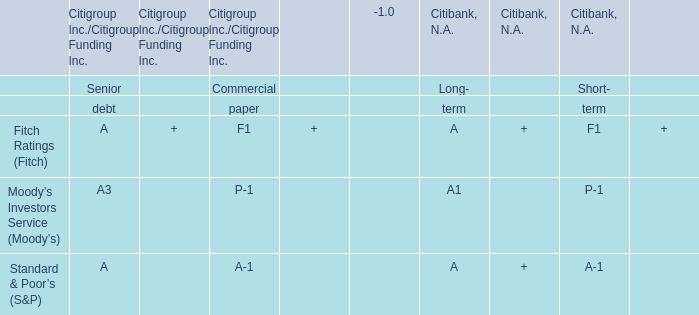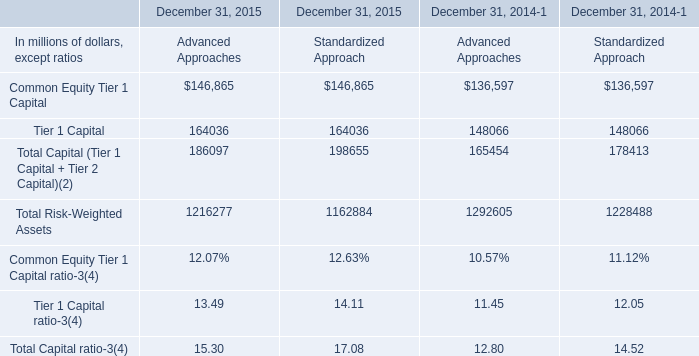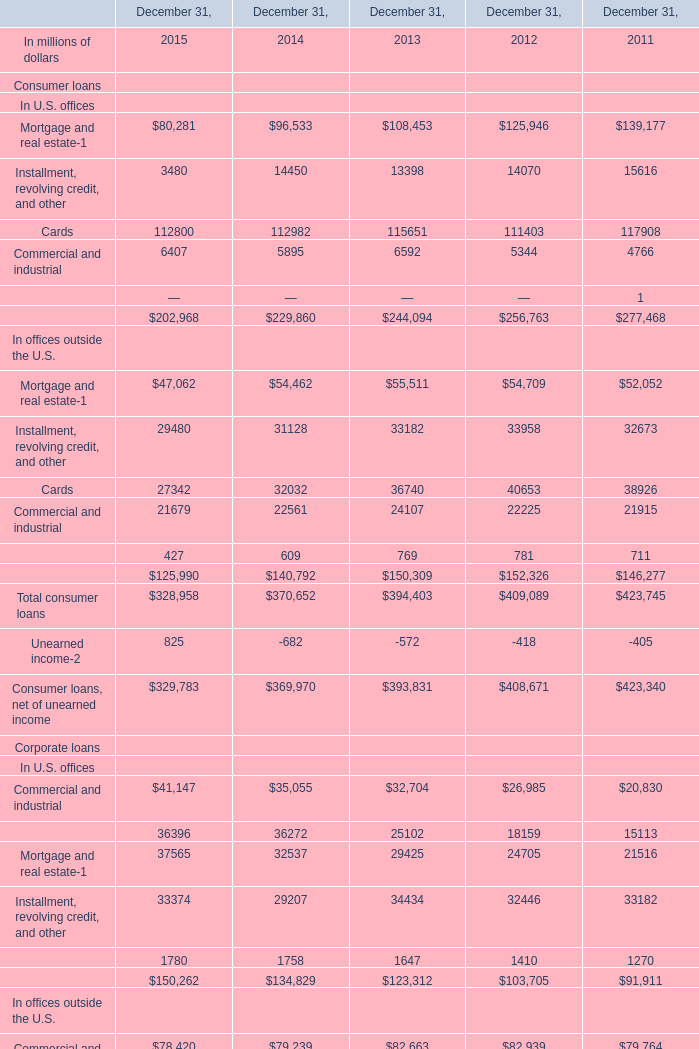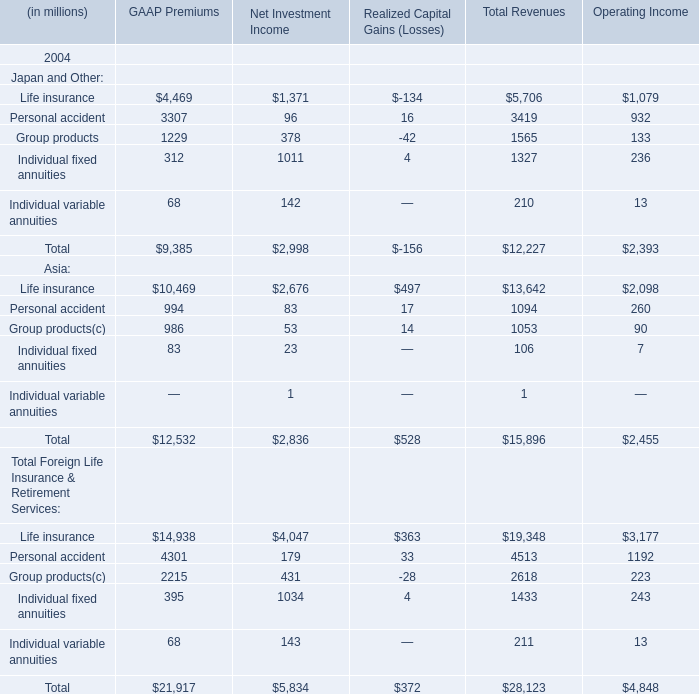What is the average amount of Group products of GAAP Premiums, and Commercial and industrial In U.S. offices of December 31, 2012 ? 
Computations: ((1229.0 + 26985.0) / 2)
Answer: 14107.0. 